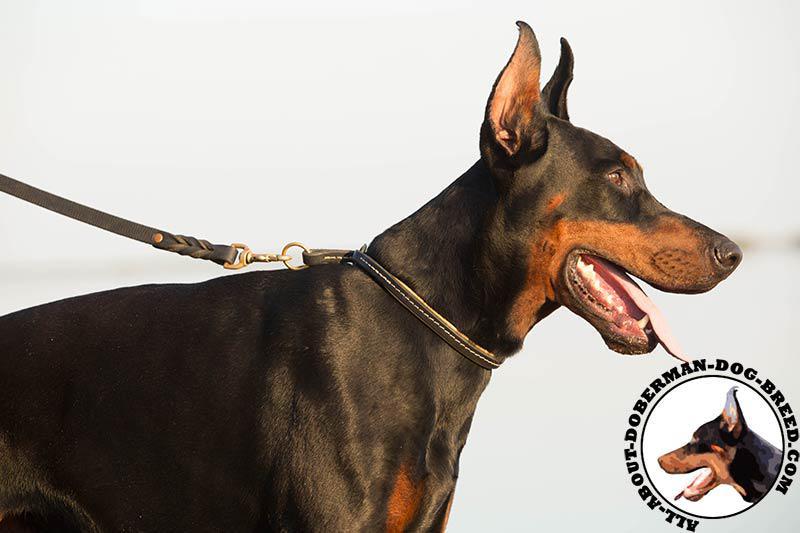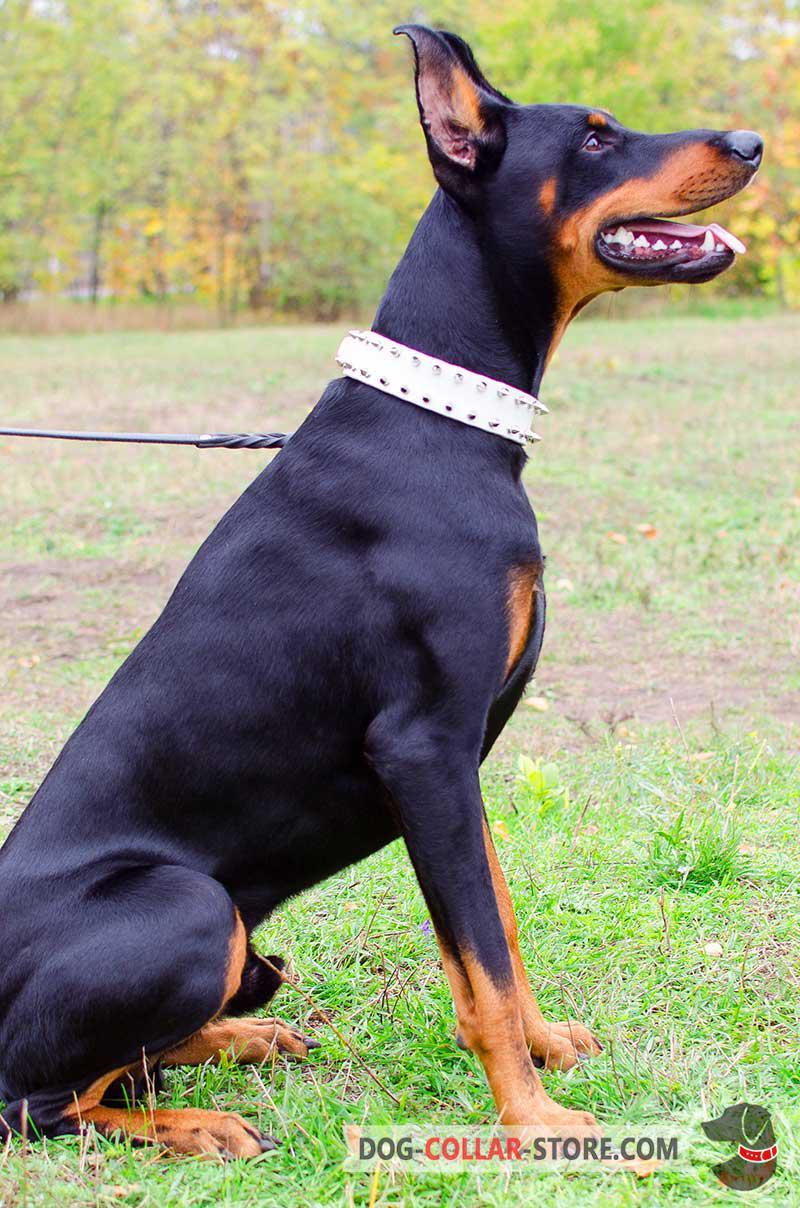The first image is the image on the left, the second image is the image on the right. Examine the images to the left and right. Is the description "Both images contain one dog that is attached the a leash." accurate? Answer yes or no. Yes. The first image is the image on the left, the second image is the image on the right. Given the left and right images, does the statement "One of the dogs is wearing a muzzle." hold true? Answer yes or no. No. 